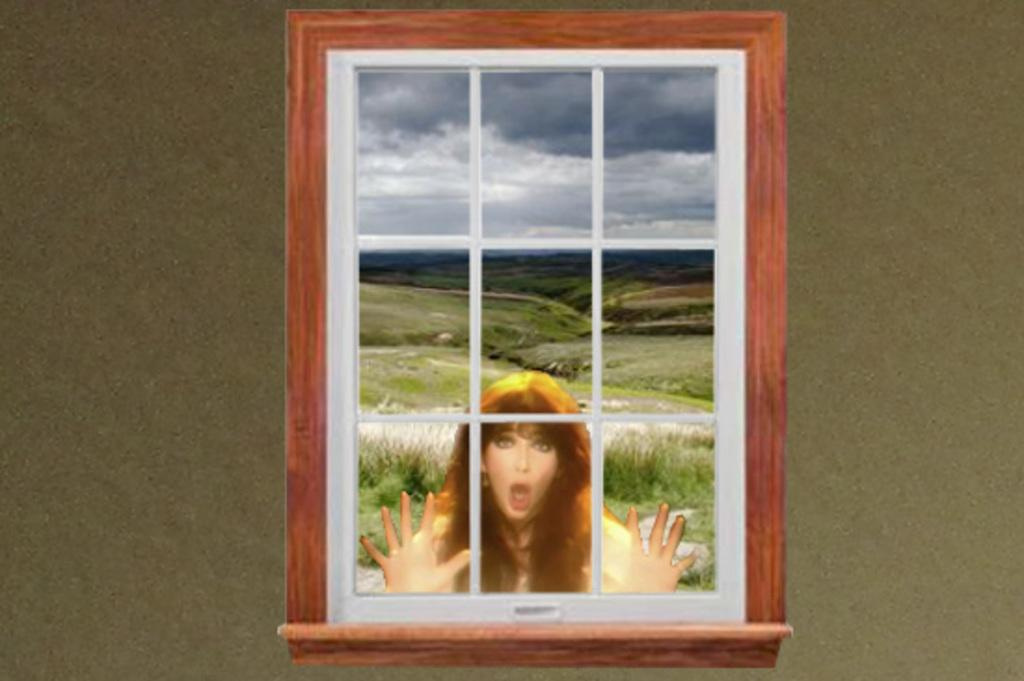What is hanging on the wall in the image? There is a frame on the wall in the image. What is depicted in the frame? The frame contains a picture of a woman. What type of natural environment can be seen in the image? There is grass visible in the image. What architectural feature is present in the image? There is a grille in the image. What part of the natural environment is visible in the image? The ground is visible in the image. What is visible in the sky in the image? The sky with clouds is visible in the image. What type of vest is the woman wearing in the image? There is no vest visible in the image, as the woman is depicted in a picture within a frame on the wall. What direction is the zephyr blowing in the image? There is no mention of a zephyr or any wind in the image; it only shows a frame with a picture of a woman, grass, a grille, the ground, and the sky with clouds. 